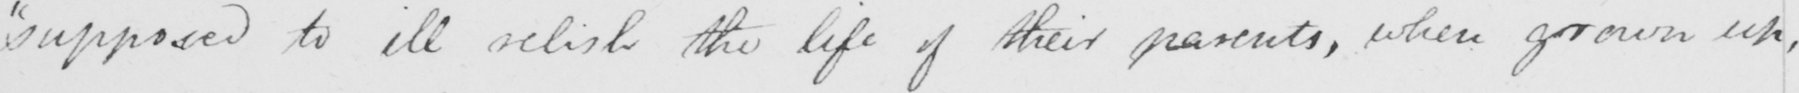Please provide the text content of this handwritten line. "supposed to ill relish the life of their parents, when grown up, 